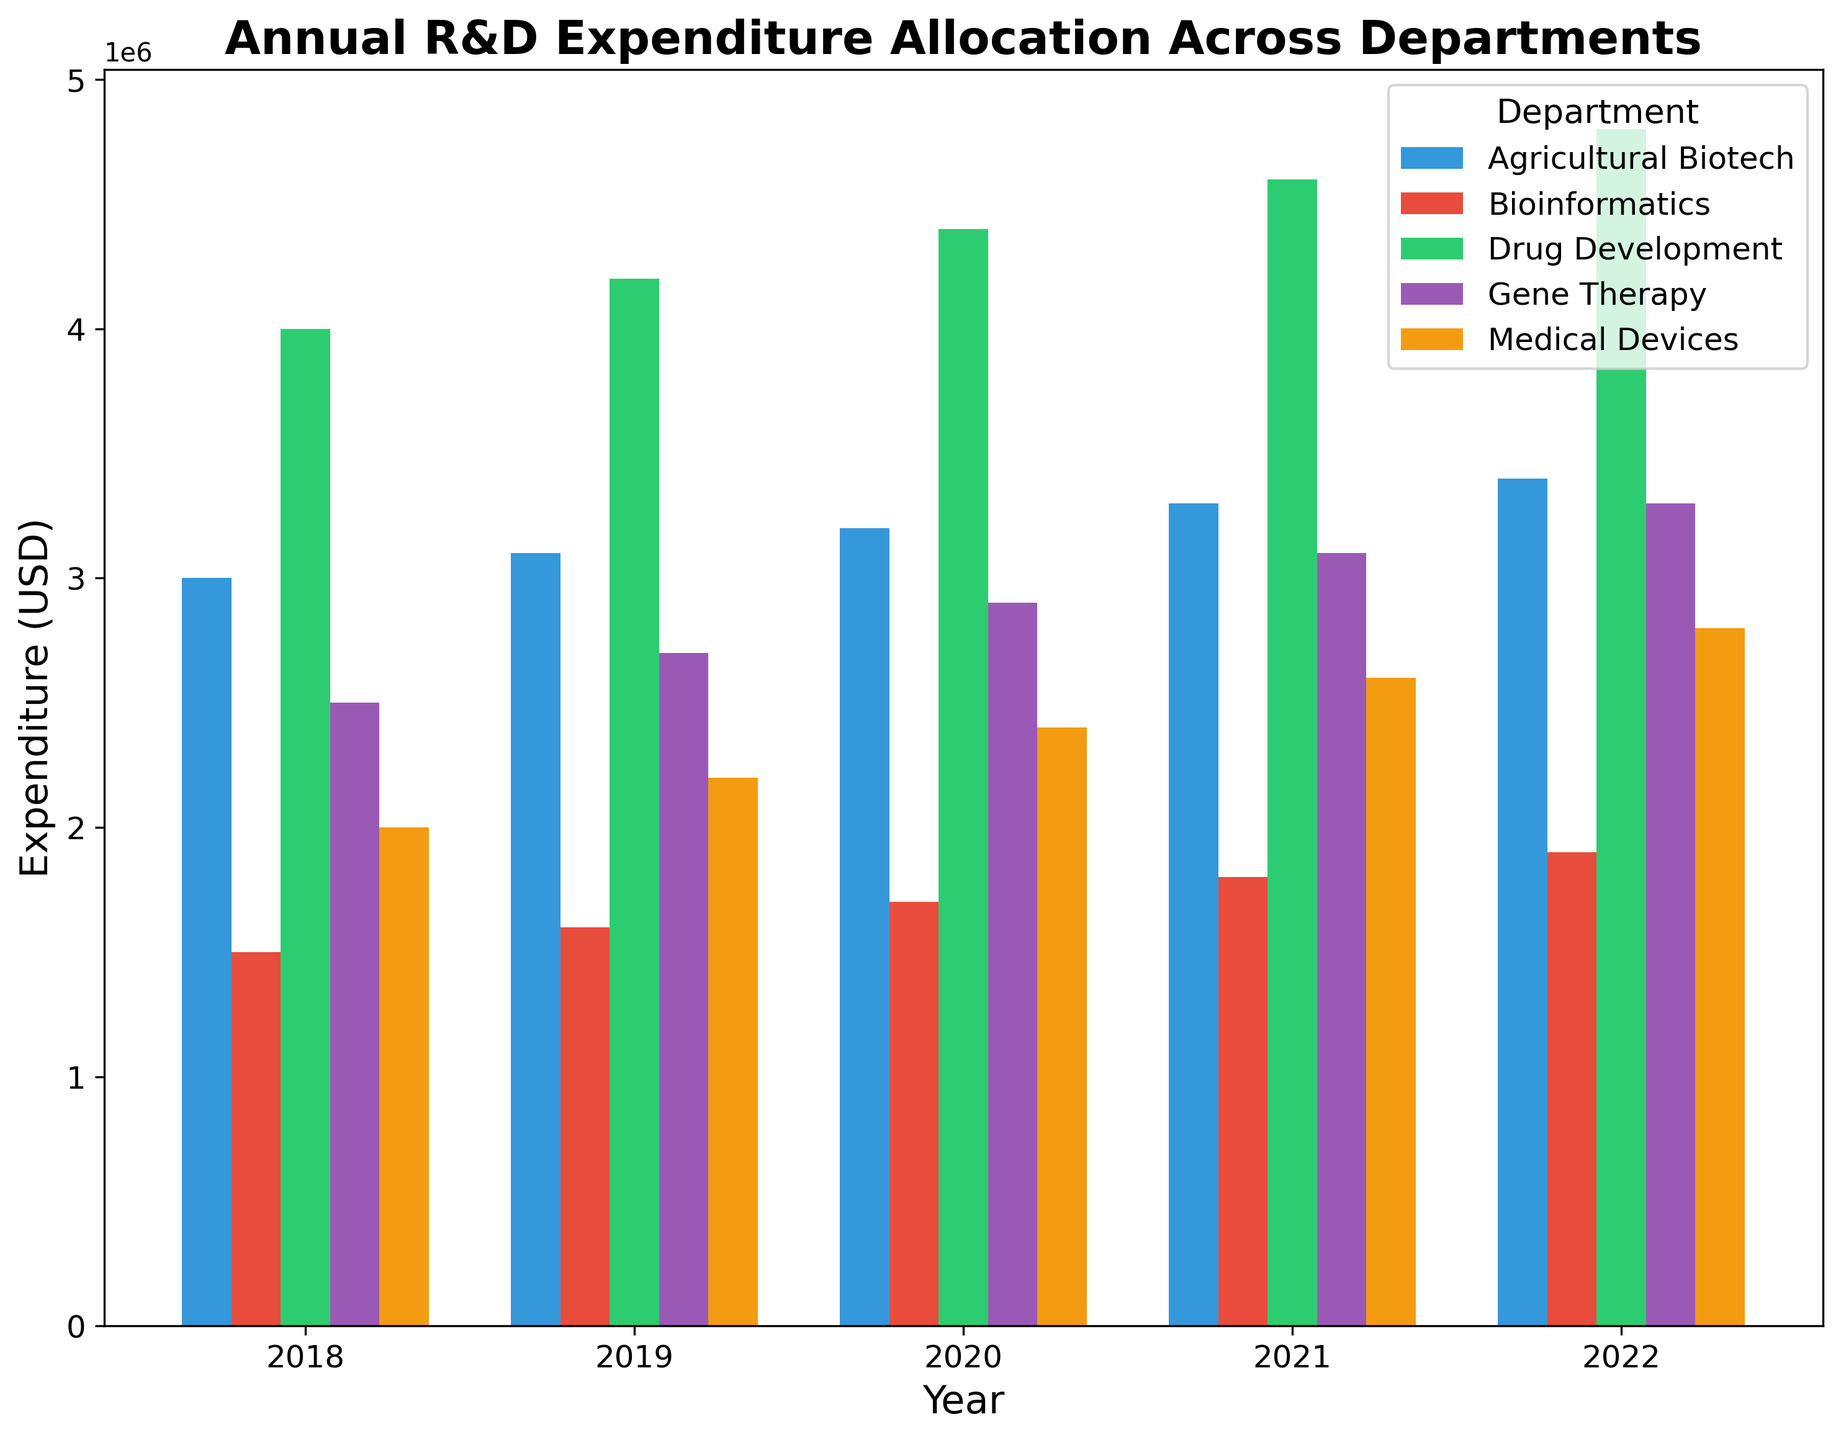What's the title of the plot? The title is located at the top of the plot in bold text. It summarizes the content of the plot.
Answer: Annual R&D Expenditure Allocation Across Departments What are the axes labels in the plot? The axes labels are typically positioned along each axis. The x-axis label represents the horizontal axis, while the y-axis label represents the vertical axis.
Answer: Year, Expenditure (USD) Which department had the highest expenditure in 2022? Look at the bars corresponding to the year 2022 in the grouped bar plot and compare their heights. The tallest bar represents the highest expenditure.
Answer: Drug Development What is the expenditure difference between the Drug Development and Bioinformatics departments in 2021? Check the heights of the bars for Drug Development and Bioinformatics in 2021, then subtract the Bioinformatics expenditure from the Drug Development expenditure.
Answer: 2,800,000 USD Which department's expenditure increased the most from 2018 to 2022? For each department, subtract the expenditure in 2018 from its expenditure in 2022 and determine which has the largest positive difference.
Answer: Drug Development In which year did Medical Devices see an expenditure of 2,200,000 USD? Look along the y-axis for the expenditure value of 2,200,000 USD and identify the year associated with the bar for Medical Devices at that height.
Answer: 2019 What is the total R&D expenditure for all departments in 2020? Sum the heights of all the bars for the year 2020 across all departments.
Answer: 14,600,000 USD How many years of data are presented in the plot? Count the number of distinct groups of bars along the x-axis, each representing a year.
Answer: 5 Which two departments had the closest expenditure figures in 2019? Compare the heights of the bars for all departments in 2019 and find the two that are nearest in value.
Answer: Agricultural Biotech and Medical Devices Did the Bioinformatics department's expenditure increase every year from 2018 to 2022? Check the heights of the bars for Bioinformatics for each year from 2018 to 2022 to see if each year's expenditure is higher than the previous year.
Answer: No 